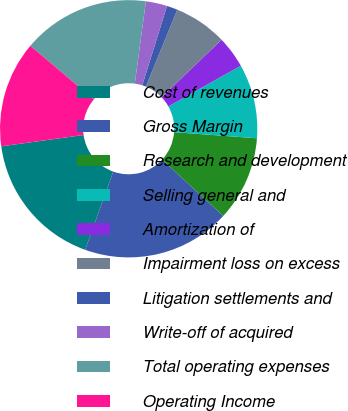Convert chart to OTSL. <chart><loc_0><loc_0><loc_500><loc_500><pie_chart><fcel>Cost of revenues<fcel>Gross Margin<fcel>Research and development<fcel>Selling general and<fcel>Amortization of<fcel>Impairment loss on excess<fcel>Litigation settlements and<fcel>Write-off of acquired<fcel>Total operating expenses<fcel>Operating Income<nl><fcel>17.32%<fcel>18.65%<fcel>10.67%<fcel>9.33%<fcel>4.01%<fcel>6.67%<fcel>1.35%<fcel>2.68%<fcel>15.99%<fcel>13.33%<nl></chart> 